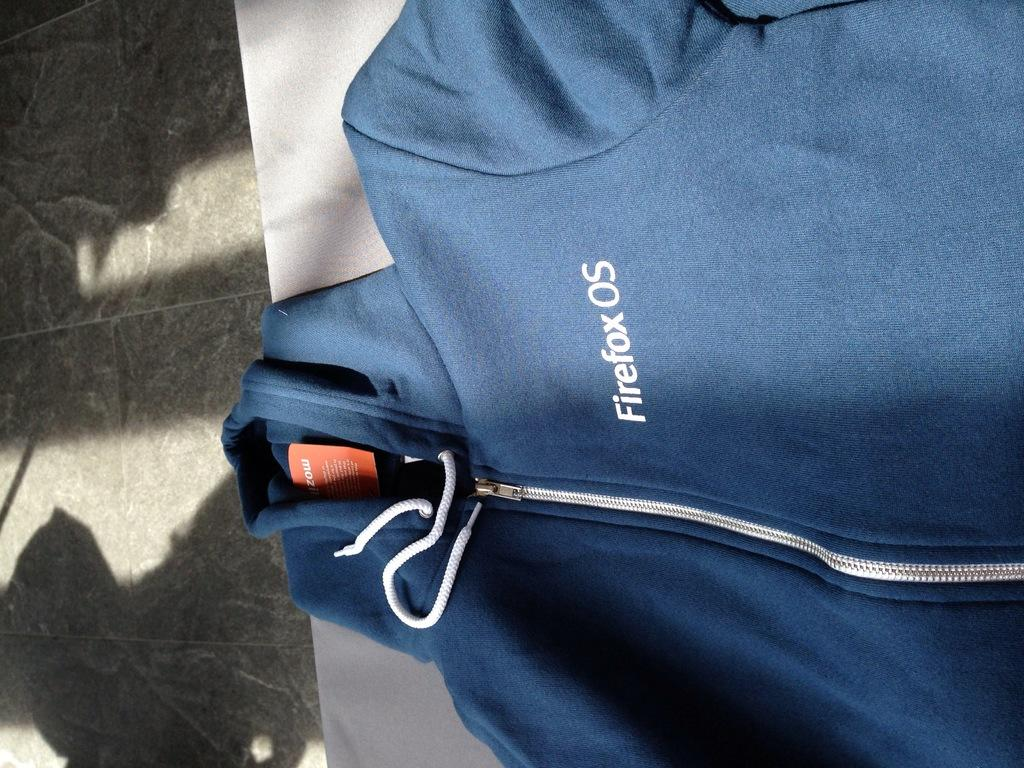What type of clothing item is in the image? There is a hoodie in the image. Where is the hoodie located? The hoodie is on a table. What part of the room can be seen on the left side of the image? The floor is visible on the left side of the image. What advice does the grandmother give about the hoodie in the image? There is no grandmother present in the image, and therefore no advice can be given. 